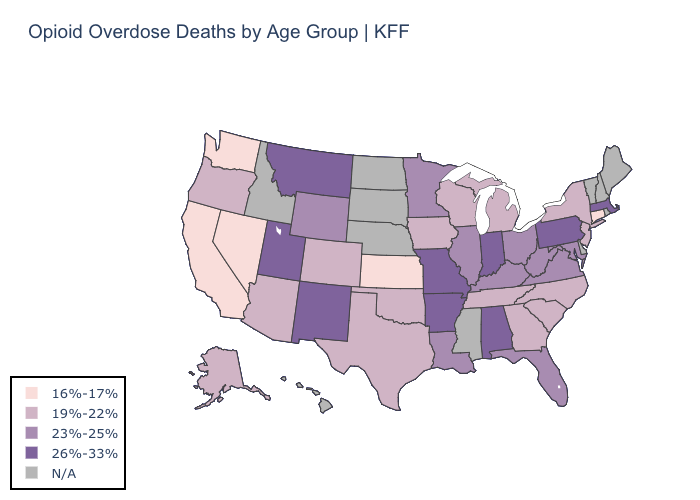Which states have the lowest value in the Northeast?
Write a very short answer. Connecticut. Is the legend a continuous bar?
Short answer required. No. What is the value of North Dakota?
Quick response, please. N/A. Which states have the highest value in the USA?
Concise answer only. Alabama, Arkansas, Indiana, Massachusetts, Missouri, Montana, New Mexico, Pennsylvania, Utah. What is the highest value in the USA?
Answer briefly. 26%-33%. What is the value of Illinois?
Concise answer only. 23%-25%. Name the states that have a value in the range 26%-33%?
Give a very brief answer. Alabama, Arkansas, Indiana, Massachusetts, Missouri, Montana, New Mexico, Pennsylvania, Utah. Name the states that have a value in the range 19%-22%?
Answer briefly. Alaska, Arizona, Colorado, Georgia, Iowa, Michigan, New Jersey, New York, North Carolina, Oklahoma, Oregon, South Carolina, Tennessee, Texas, Wisconsin. Name the states that have a value in the range 26%-33%?
Answer briefly. Alabama, Arkansas, Indiana, Massachusetts, Missouri, Montana, New Mexico, Pennsylvania, Utah. Does California have the lowest value in the USA?
Give a very brief answer. Yes. What is the value of Missouri?
Be succinct. 26%-33%. What is the lowest value in states that border Texas?
Concise answer only. 19%-22%. What is the highest value in the Northeast ?
Write a very short answer. 26%-33%. 